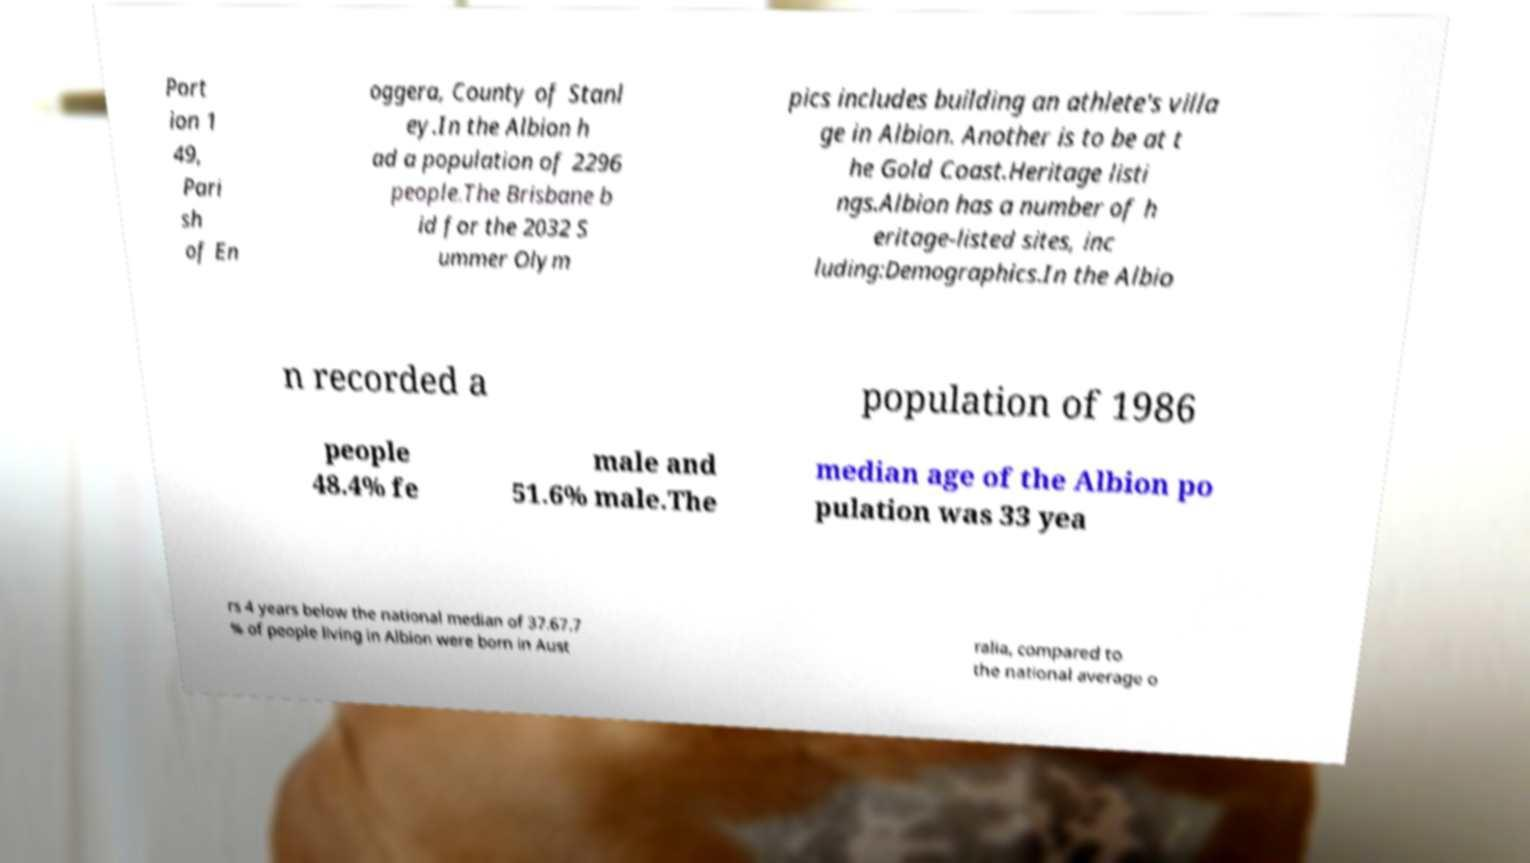Please read and relay the text visible in this image. What does it say? Port ion 1 49, Pari sh of En oggera, County of Stanl ey.In the Albion h ad a population of 2296 people.The Brisbane b id for the 2032 S ummer Olym pics includes building an athlete's villa ge in Albion. Another is to be at t he Gold Coast.Heritage listi ngs.Albion has a number of h eritage-listed sites, inc luding:Demographics.In the Albio n recorded a population of 1986 people 48.4% fe male and 51.6% male.The median age of the Albion po pulation was 33 yea rs 4 years below the national median of 37.67.7 % of people living in Albion were born in Aust ralia, compared to the national average o 